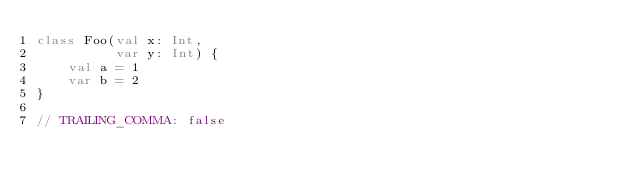<code> <loc_0><loc_0><loc_500><loc_500><_Kotlin_>class Foo(val x: Int,
          var y: Int) {
    val a = 1
    var b = 2
}

// TRAILING_COMMA: false</code> 